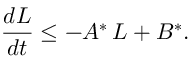<formula> <loc_0><loc_0><loc_500><loc_500>\frac { d L } { d t } \leq - A ^ { * } \, L + B ^ { * } .</formula> 